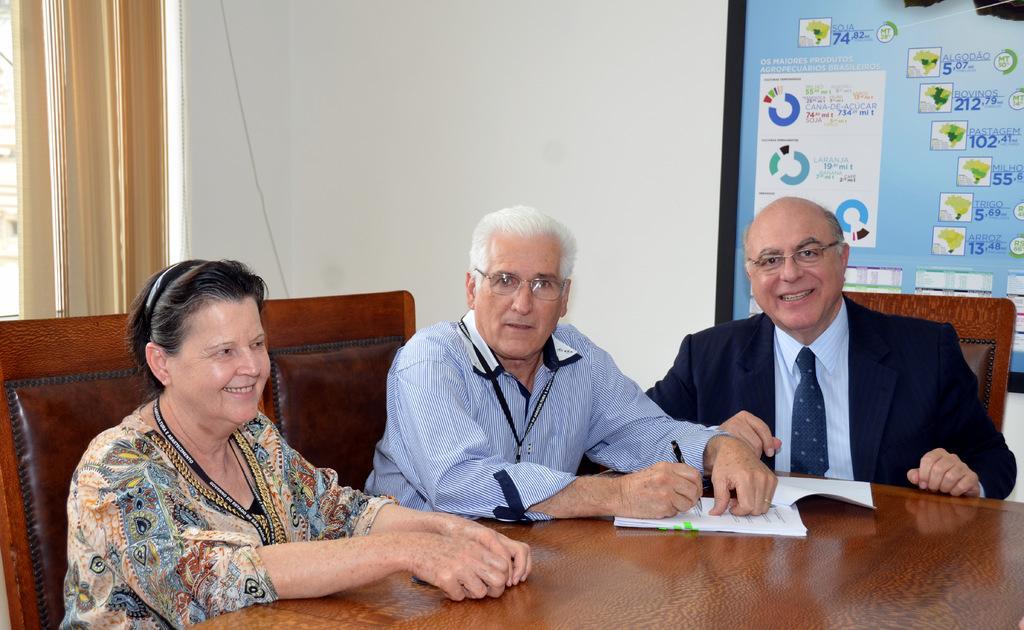Can you describe this image briefly? There are persons in different color dresses, smiling and sitting on chairs. One of them is holding a pen with a hand and keeping the other hand on the book. In the background, there is a screen attached to the white wall. 